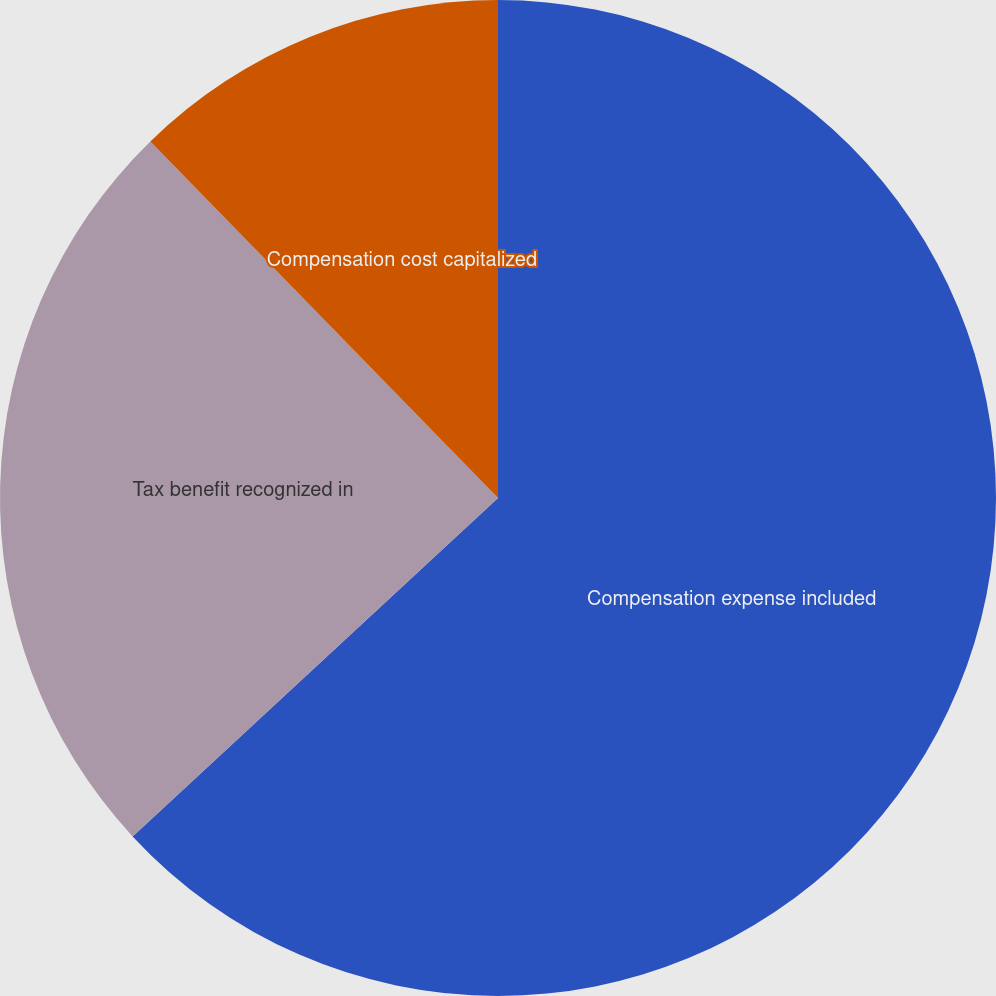Convert chart to OTSL. <chart><loc_0><loc_0><loc_500><loc_500><pie_chart><fcel>Compensation expense included<fcel>Tax benefit recognized in<fcel>Compensation cost capitalized<nl><fcel>63.11%<fcel>24.59%<fcel>12.3%<nl></chart> 